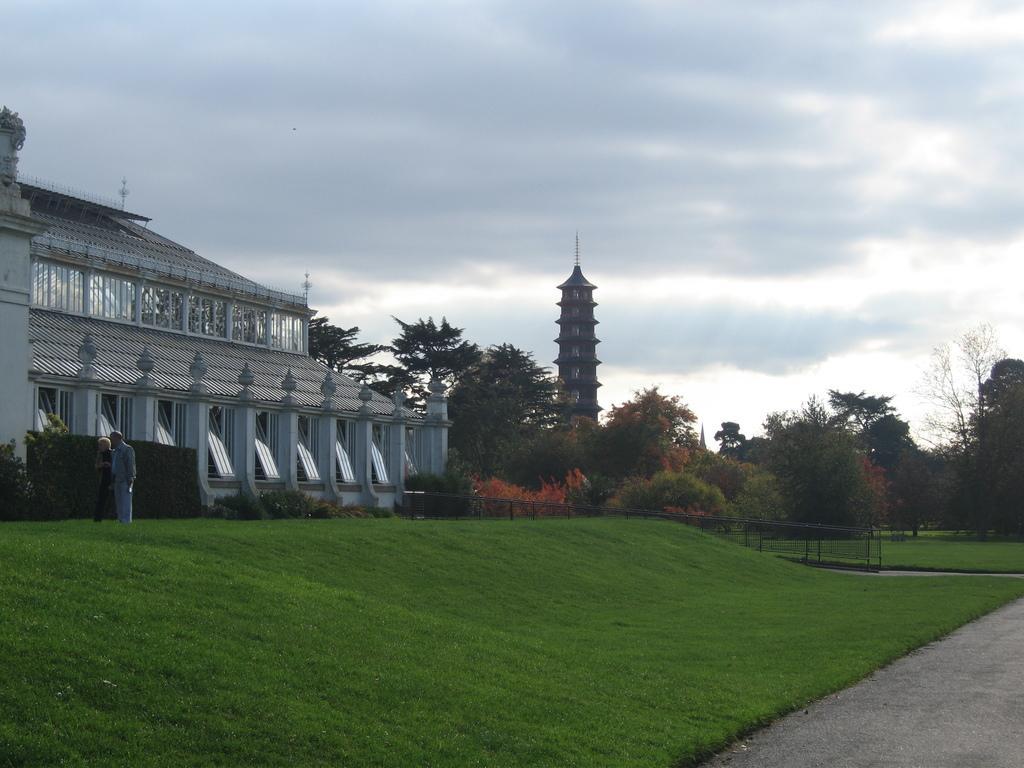In one or two sentences, can you explain what this image depicts? In the picture we can see a part of the path and beside it, we can see a grass surface on it, we can see some plants and house and near it, we can see a man standing and beside the house we can see some plants and trees and some pillar construction and behind it we can see a sky with clouds. 